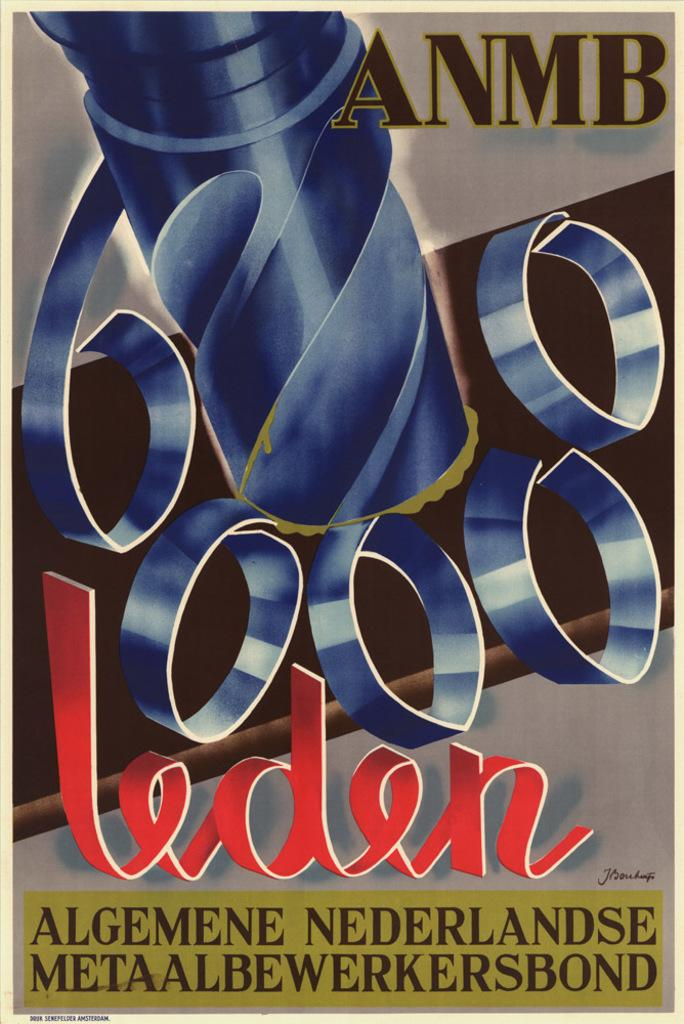<image>
Provide a brief description of the given image. A poster displays the letters ANMB in the upper right corner. 